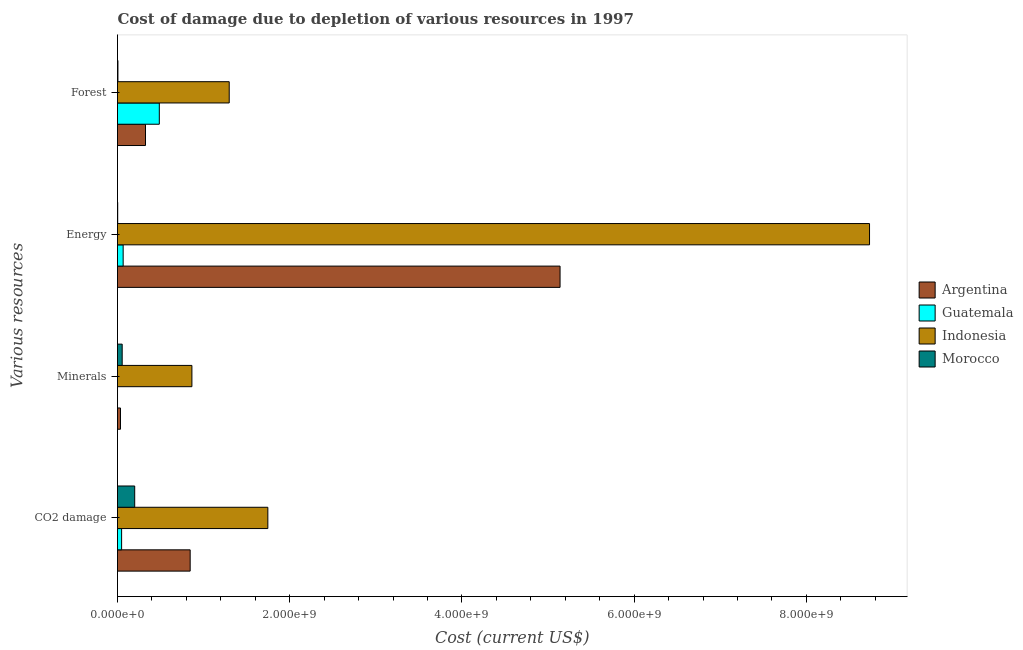Are the number of bars per tick equal to the number of legend labels?
Provide a succinct answer. Yes. How many bars are there on the 3rd tick from the top?
Your answer should be compact. 4. What is the label of the 1st group of bars from the top?
Give a very brief answer. Forest. What is the cost of damage due to depletion of energy in Morocco?
Ensure brevity in your answer.  2.38e+06. Across all countries, what is the maximum cost of damage due to depletion of forests?
Your answer should be compact. 1.30e+09. Across all countries, what is the minimum cost of damage due to depletion of forests?
Make the answer very short. 4.94e+06. In which country was the cost of damage due to depletion of forests maximum?
Give a very brief answer. Indonesia. In which country was the cost of damage due to depletion of energy minimum?
Your answer should be very brief. Morocco. What is the total cost of damage due to depletion of minerals in the graph?
Offer a very short reply. 9.53e+08. What is the difference between the cost of damage due to depletion of energy in Morocco and that in Argentina?
Your answer should be compact. -5.14e+09. What is the difference between the cost of damage due to depletion of forests in Morocco and the cost of damage due to depletion of coal in Indonesia?
Offer a very short reply. -1.74e+09. What is the average cost of damage due to depletion of minerals per country?
Ensure brevity in your answer.  2.38e+08. What is the difference between the cost of damage due to depletion of energy and cost of damage due to depletion of forests in Morocco?
Make the answer very short. -2.56e+06. What is the ratio of the cost of damage due to depletion of energy in Morocco to that in Indonesia?
Ensure brevity in your answer.  0. What is the difference between the highest and the second highest cost of damage due to depletion of forests?
Provide a succinct answer. 8.12e+08. What is the difference between the highest and the lowest cost of damage due to depletion of minerals?
Provide a short and direct response. 8.64e+08. In how many countries, is the cost of damage due to depletion of coal greater than the average cost of damage due to depletion of coal taken over all countries?
Provide a short and direct response. 2. Is the sum of the cost of damage due to depletion of coal in Indonesia and Guatemala greater than the maximum cost of damage due to depletion of minerals across all countries?
Provide a short and direct response. Yes. Is it the case that in every country, the sum of the cost of damage due to depletion of minerals and cost of damage due to depletion of coal is greater than the sum of cost of damage due to depletion of forests and cost of damage due to depletion of energy?
Your answer should be very brief. No. What does the 2nd bar from the top in Minerals represents?
Provide a short and direct response. Indonesia. What does the 1st bar from the bottom in CO2 damage represents?
Keep it short and to the point. Argentina. Is it the case that in every country, the sum of the cost of damage due to depletion of coal and cost of damage due to depletion of minerals is greater than the cost of damage due to depletion of energy?
Offer a terse response. No. Are all the bars in the graph horizontal?
Make the answer very short. Yes. Are the values on the major ticks of X-axis written in scientific E-notation?
Offer a very short reply. Yes. Does the graph contain grids?
Make the answer very short. No. Where does the legend appear in the graph?
Ensure brevity in your answer.  Center right. How are the legend labels stacked?
Ensure brevity in your answer.  Vertical. What is the title of the graph?
Your answer should be compact. Cost of damage due to depletion of various resources in 1997 . What is the label or title of the X-axis?
Your answer should be compact. Cost (current US$). What is the label or title of the Y-axis?
Keep it short and to the point. Various resources. What is the Cost (current US$) of Argentina in CO2 damage?
Keep it short and to the point. 8.44e+08. What is the Cost (current US$) in Guatemala in CO2 damage?
Ensure brevity in your answer.  4.76e+07. What is the Cost (current US$) of Indonesia in CO2 damage?
Offer a very short reply. 1.75e+09. What is the Cost (current US$) in Morocco in CO2 damage?
Offer a very short reply. 2.00e+08. What is the Cost (current US$) in Argentina in Minerals?
Your answer should be compact. 3.46e+07. What is the Cost (current US$) of Guatemala in Minerals?
Provide a succinct answer. 8.35e+04. What is the Cost (current US$) in Indonesia in Minerals?
Your answer should be compact. 8.64e+08. What is the Cost (current US$) in Morocco in Minerals?
Provide a short and direct response. 5.44e+07. What is the Cost (current US$) in Argentina in Energy?
Your answer should be very brief. 5.14e+09. What is the Cost (current US$) of Guatemala in Energy?
Offer a terse response. 6.56e+07. What is the Cost (current US$) in Indonesia in Energy?
Make the answer very short. 8.73e+09. What is the Cost (current US$) of Morocco in Energy?
Keep it short and to the point. 2.38e+06. What is the Cost (current US$) of Argentina in Forest?
Your response must be concise. 3.25e+08. What is the Cost (current US$) in Guatemala in Forest?
Keep it short and to the point. 4.85e+08. What is the Cost (current US$) of Indonesia in Forest?
Your answer should be compact. 1.30e+09. What is the Cost (current US$) of Morocco in Forest?
Offer a very short reply. 4.94e+06. Across all Various resources, what is the maximum Cost (current US$) in Argentina?
Your answer should be very brief. 5.14e+09. Across all Various resources, what is the maximum Cost (current US$) in Guatemala?
Ensure brevity in your answer.  4.85e+08. Across all Various resources, what is the maximum Cost (current US$) in Indonesia?
Keep it short and to the point. 8.73e+09. Across all Various resources, what is the maximum Cost (current US$) of Morocco?
Keep it short and to the point. 2.00e+08. Across all Various resources, what is the minimum Cost (current US$) in Argentina?
Ensure brevity in your answer.  3.46e+07. Across all Various resources, what is the minimum Cost (current US$) in Guatemala?
Offer a terse response. 8.35e+04. Across all Various resources, what is the minimum Cost (current US$) in Indonesia?
Your answer should be compact. 8.64e+08. Across all Various resources, what is the minimum Cost (current US$) in Morocco?
Ensure brevity in your answer.  2.38e+06. What is the total Cost (current US$) of Argentina in the graph?
Offer a terse response. 6.34e+09. What is the total Cost (current US$) of Guatemala in the graph?
Keep it short and to the point. 5.99e+08. What is the total Cost (current US$) in Indonesia in the graph?
Provide a succinct answer. 1.26e+1. What is the total Cost (current US$) of Morocco in the graph?
Your response must be concise. 2.61e+08. What is the difference between the Cost (current US$) of Argentina in CO2 damage and that in Minerals?
Your answer should be compact. 8.09e+08. What is the difference between the Cost (current US$) in Guatemala in CO2 damage and that in Minerals?
Give a very brief answer. 4.75e+07. What is the difference between the Cost (current US$) in Indonesia in CO2 damage and that in Minerals?
Make the answer very short. 8.82e+08. What is the difference between the Cost (current US$) in Morocco in CO2 damage and that in Minerals?
Your answer should be very brief. 1.45e+08. What is the difference between the Cost (current US$) of Argentina in CO2 damage and that in Energy?
Provide a succinct answer. -4.30e+09. What is the difference between the Cost (current US$) of Guatemala in CO2 damage and that in Energy?
Your answer should be very brief. -1.80e+07. What is the difference between the Cost (current US$) in Indonesia in CO2 damage and that in Energy?
Keep it short and to the point. -6.99e+09. What is the difference between the Cost (current US$) of Morocco in CO2 damage and that in Energy?
Your response must be concise. 1.97e+08. What is the difference between the Cost (current US$) of Argentina in CO2 damage and that in Forest?
Your answer should be very brief. 5.19e+08. What is the difference between the Cost (current US$) in Guatemala in CO2 damage and that in Forest?
Provide a succinct answer. -4.38e+08. What is the difference between the Cost (current US$) in Indonesia in CO2 damage and that in Forest?
Give a very brief answer. 4.49e+08. What is the difference between the Cost (current US$) of Morocco in CO2 damage and that in Forest?
Offer a terse response. 1.95e+08. What is the difference between the Cost (current US$) in Argentina in Minerals and that in Energy?
Your answer should be very brief. -5.10e+09. What is the difference between the Cost (current US$) in Guatemala in Minerals and that in Energy?
Offer a very short reply. -6.56e+07. What is the difference between the Cost (current US$) of Indonesia in Minerals and that in Energy?
Keep it short and to the point. -7.87e+09. What is the difference between the Cost (current US$) in Morocco in Minerals and that in Energy?
Give a very brief answer. 5.20e+07. What is the difference between the Cost (current US$) of Argentina in Minerals and that in Forest?
Your answer should be very brief. -2.91e+08. What is the difference between the Cost (current US$) in Guatemala in Minerals and that in Forest?
Your answer should be very brief. -4.85e+08. What is the difference between the Cost (current US$) of Indonesia in Minerals and that in Forest?
Give a very brief answer. -4.33e+08. What is the difference between the Cost (current US$) of Morocco in Minerals and that in Forest?
Give a very brief answer. 4.94e+07. What is the difference between the Cost (current US$) of Argentina in Energy and that in Forest?
Your answer should be compact. 4.81e+09. What is the difference between the Cost (current US$) in Guatemala in Energy and that in Forest?
Provide a short and direct response. -4.20e+08. What is the difference between the Cost (current US$) in Indonesia in Energy and that in Forest?
Your response must be concise. 7.44e+09. What is the difference between the Cost (current US$) of Morocco in Energy and that in Forest?
Your answer should be very brief. -2.56e+06. What is the difference between the Cost (current US$) in Argentina in CO2 damage and the Cost (current US$) in Guatemala in Minerals?
Offer a terse response. 8.44e+08. What is the difference between the Cost (current US$) in Argentina in CO2 damage and the Cost (current US$) in Indonesia in Minerals?
Make the answer very short. -2.02e+07. What is the difference between the Cost (current US$) in Argentina in CO2 damage and the Cost (current US$) in Morocco in Minerals?
Offer a terse response. 7.89e+08. What is the difference between the Cost (current US$) in Guatemala in CO2 damage and the Cost (current US$) in Indonesia in Minerals?
Provide a short and direct response. -8.16e+08. What is the difference between the Cost (current US$) of Guatemala in CO2 damage and the Cost (current US$) of Morocco in Minerals?
Keep it short and to the point. -6.76e+06. What is the difference between the Cost (current US$) in Indonesia in CO2 damage and the Cost (current US$) in Morocco in Minerals?
Your answer should be compact. 1.69e+09. What is the difference between the Cost (current US$) in Argentina in CO2 damage and the Cost (current US$) in Guatemala in Energy?
Ensure brevity in your answer.  7.78e+08. What is the difference between the Cost (current US$) in Argentina in CO2 damage and the Cost (current US$) in Indonesia in Energy?
Offer a terse response. -7.89e+09. What is the difference between the Cost (current US$) in Argentina in CO2 damage and the Cost (current US$) in Morocco in Energy?
Your answer should be compact. 8.41e+08. What is the difference between the Cost (current US$) in Guatemala in CO2 damage and the Cost (current US$) in Indonesia in Energy?
Provide a succinct answer. -8.69e+09. What is the difference between the Cost (current US$) of Guatemala in CO2 damage and the Cost (current US$) of Morocco in Energy?
Your answer should be compact. 4.52e+07. What is the difference between the Cost (current US$) of Indonesia in CO2 damage and the Cost (current US$) of Morocco in Energy?
Your response must be concise. 1.74e+09. What is the difference between the Cost (current US$) in Argentina in CO2 damage and the Cost (current US$) in Guatemala in Forest?
Your response must be concise. 3.58e+08. What is the difference between the Cost (current US$) of Argentina in CO2 damage and the Cost (current US$) of Indonesia in Forest?
Provide a succinct answer. -4.54e+08. What is the difference between the Cost (current US$) of Argentina in CO2 damage and the Cost (current US$) of Morocco in Forest?
Provide a succinct answer. 8.39e+08. What is the difference between the Cost (current US$) in Guatemala in CO2 damage and the Cost (current US$) in Indonesia in Forest?
Keep it short and to the point. -1.25e+09. What is the difference between the Cost (current US$) of Guatemala in CO2 damage and the Cost (current US$) of Morocco in Forest?
Provide a short and direct response. 4.27e+07. What is the difference between the Cost (current US$) of Indonesia in CO2 damage and the Cost (current US$) of Morocco in Forest?
Keep it short and to the point. 1.74e+09. What is the difference between the Cost (current US$) of Argentina in Minerals and the Cost (current US$) of Guatemala in Energy?
Provide a succinct answer. -3.10e+07. What is the difference between the Cost (current US$) in Argentina in Minerals and the Cost (current US$) in Indonesia in Energy?
Your response must be concise. -8.70e+09. What is the difference between the Cost (current US$) in Argentina in Minerals and the Cost (current US$) in Morocco in Energy?
Give a very brief answer. 3.22e+07. What is the difference between the Cost (current US$) in Guatemala in Minerals and the Cost (current US$) in Indonesia in Energy?
Offer a very short reply. -8.73e+09. What is the difference between the Cost (current US$) in Guatemala in Minerals and the Cost (current US$) in Morocco in Energy?
Make the answer very short. -2.30e+06. What is the difference between the Cost (current US$) in Indonesia in Minerals and the Cost (current US$) in Morocco in Energy?
Your answer should be very brief. 8.62e+08. What is the difference between the Cost (current US$) of Argentina in Minerals and the Cost (current US$) of Guatemala in Forest?
Your response must be concise. -4.51e+08. What is the difference between the Cost (current US$) of Argentina in Minerals and the Cost (current US$) of Indonesia in Forest?
Provide a short and direct response. -1.26e+09. What is the difference between the Cost (current US$) in Argentina in Minerals and the Cost (current US$) in Morocco in Forest?
Offer a terse response. 2.97e+07. What is the difference between the Cost (current US$) of Guatemala in Minerals and the Cost (current US$) of Indonesia in Forest?
Keep it short and to the point. -1.30e+09. What is the difference between the Cost (current US$) in Guatemala in Minerals and the Cost (current US$) in Morocco in Forest?
Your answer should be very brief. -4.85e+06. What is the difference between the Cost (current US$) in Indonesia in Minerals and the Cost (current US$) in Morocco in Forest?
Your response must be concise. 8.59e+08. What is the difference between the Cost (current US$) in Argentina in Energy and the Cost (current US$) in Guatemala in Forest?
Your answer should be compact. 4.65e+09. What is the difference between the Cost (current US$) in Argentina in Energy and the Cost (current US$) in Indonesia in Forest?
Your answer should be very brief. 3.84e+09. What is the difference between the Cost (current US$) of Argentina in Energy and the Cost (current US$) of Morocco in Forest?
Make the answer very short. 5.13e+09. What is the difference between the Cost (current US$) of Guatemala in Energy and the Cost (current US$) of Indonesia in Forest?
Provide a succinct answer. -1.23e+09. What is the difference between the Cost (current US$) of Guatemala in Energy and the Cost (current US$) of Morocco in Forest?
Make the answer very short. 6.07e+07. What is the difference between the Cost (current US$) of Indonesia in Energy and the Cost (current US$) of Morocco in Forest?
Your answer should be very brief. 8.73e+09. What is the average Cost (current US$) of Argentina per Various resources?
Provide a succinct answer. 1.59e+09. What is the average Cost (current US$) in Guatemala per Various resources?
Keep it short and to the point. 1.50e+08. What is the average Cost (current US$) in Indonesia per Various resources?
Give a very brief answer. 3.16e+09. What is the average Cost (current US$) of Morocco per Various resources?
Keep it short and to the point. 6.53e+07. What is the difference between the Cost (current US$) in Argentina and Cost (current US$) in Guatemala in CO2 damage?
Give a very brief answer. 7.96e+08. What is the difference between the Cost (current US$) of Argentina and Cost (current US$) of Indonesia in CO2 damage?
Offer a terse response. -9.02e+08. What is the difference between the Cost (current US$) in Argentina and Cost (current US$) in Morocco in CO2 damage?
Offer a terse response. 6.44e+08. What is the difference between the Cost (current US$) in Guatemala and Cost (current US$) in Indonesia in CO2 damage?
Keep it short and to the point. -1.70e+09. What is the difference between the Cost (current US$) of Guatemala and Cost (current US$) of Morocco in CO2 damage?
Your response must be concise. -1.52e+08. What is the difference between the Cost (current US$) in Indonesia and Cost (current US$) in Morocco in CO2 damage?
Your answer should be compact. 1.55e+09. What is the difference between the Cost (current US$) of Argentina and Cost (current US$) of Guatemala in Minerals?
Ensure brevity in your answer.  3.45e+07. What is the difference between the Cost (current US$) in Argentina and Cost (current US$) in Indonesia in Minerals?
Give a very brief answer. -8.29e+08. What is the difference between the Cost (current US$) of Argentina and Cost (current US$) of Morocco in Minerals?
Keep it short and to the point. -1.98e+07. What is the difference between the Cost (current US$) of Guatemala and Cost (current US$) of Indonesia in Minerals?
Keep it short and to the point. -8.64e+08. What is the difference between the Cost (current US$) of Guatemala and Cost (current US$) of Morocco in Minerals?
Give a very brief answer. -5.43e+07. What is the difference between the Cost (current US$) of Indonesia and Cost (current US$) of Morocco in Minerals?
Ensure brevity in your answer.  8.10e+08. What is the difference between the Cost (current US$) in Argentina and Cost (current US$) in Guatemala in Energy?
Offer a very short reply. 5.07e+09. What is the difference between the Cost (current US$) of Argentina and Cost (current US$) of Indonesia in Energy?
Your answer should be very brief. -3.59e+09. What is the difference between the Cost (current US$) in Argentina and Cost (current US$) in Morocco in Energy?
Your answer should be compact. 5.14e+09. What is the difference between the Cost (current US$) of Guatemala and Cost (current US$) of Indonesia in Energy?
Your answer should be compact. -8.67e+09. What is the difference between the Cost (current US$) of Guatemala and Cost (current US$) of Morocco in Energy?
Your answer should be compact. 6.33e+07. What is the difference between the Cost (current US$) in Indonesia and Cost (current US$) in Morocco in Energy?
Your answer should be compact. 8.73e+09. What is the difference between the Cost (current US$) in Argentina and Cost (current US$) in Guatemala in Forest?
Offer a very short reply. -1.60e+08. What is the difference between the Cost (current US$) in Argentina and Cost (current US$) in Indonesia in Forest?
Offer a very short reply. -9.72e+08. What is the difference between the Cost (current US$) of Argentina and Cost (current US$) of Morocco in Forest?
Offer a terse response. 3.20e+08. What is the difference between the Cost (current US$) in Guatemala and Cost (current US$) in Indonesia in Forest?
Provide a short and direct response. -8.12e+08. What is the difference between the Cost (current US$) of Guatemala and Cost (current US$) of Morocco in Forest?
Keep it short and to the point. 4.80e+08. What is the difference between the Cost (current US$) in Indonesia and Cost (current US$) in Morocco in Forest?
Offer a terse response. 1.29e+09. What is the ratio of the Cost (current US$) of Argentina in CO2 damage to that in Minerals?
Your answer should be compact. 24.39. What is the ratio of the Cost (current US$) in Guatemala in CO2 damage to that in Minerals?
Give a very brief answer. 569.95. What is the ratio of the Cost (current US$) of Indonesia in CO2 damage to that in Minerals?
Make the answer very short. 2.02. What is the ratio of the Cost (current US$) in Morocco in CO2 damage to that in Minerals?
Provide a succinct answer. 3.67. What is the ratio of the Cost (current US$) in Argentina in CO2 damage to that in Energy?
Your answer should be very brief. 0.16. What is the ratio of the Cost (current US$) of Guatemala in CO2 damage to that in Energy?
Ensure brevity in your answer.  0.73. What is the ratio of the Cost (current US$) in Indonesia in CO2 damage to that in Energy?
Offer a very short reply. 0.2. What is the ratio of the Cost (current US$) of Morocco in CO2 damage to that in Energy?
Offer a very short reply. 83.87. What is the ratio of the Cost (current US$) in Argentina in CO2 damage to that in Forest?
Make the answer very short. 2.6. What is the ratio of the Cost (current US$) in Guatemala in CO2 damage to that in Forest?
Your response must be concise. 0.1. What is the ratio of the Cost (current US$) of Indonesia in CO2 damage to that in Forest?
Give a very brief answer. 1.35. What is the ratio of the Cost (current US$) in Morocco in CO2 damage to that in Forest?
Offer a terse response. 40.43. What is the ratio of the Cost (current US$) in Argentina in Minerals to that in Energy?
Your response must be concise. 0.01. What is the ratio of the Cost (current US$) of Guatemala in Minerals to that in Energy?
Keep it short and to the point. 0. What is the ratio of the Cost (current US$) of Indonesia in Minerals to that in Energy?
Keep it short and to the point. 0.1. What is the ratio of the Cost (current US$) in Morocco in Minerals to that in Energy?
Offer a terse response. 22.84. What is the ratio of the Cost (current US$) of Argentina in Minerals to that in Forest?
Provide a succinct answer. 0.11. What is the ratio of the Cost (current US$) in Guatemala in Minerals to that in Forest?
Your response must be concise. 0. What is the ratio of the Cost (current US$) in Indonesia in Minerals to that in Forest?
Provide a short and direct response. 0.67. What is the ratio of the Cost (current US$) in Morocco in Minerals to that in Forest?
Make the answer very short. 11.01. What is the ratio of the Cost (current US$) in Argentina in Energy to that in Forest?
Ensure brevity in your answer.  15.81. What is the ratio of the Cost (current US$) of Guatemala in Energy to that in Forest?
Your answer should be very brief. 0.14. What is the ratio of the Cost (current US$) in Indonesia in Energy to that in Forest?
Make the answer very short. 6.73. What is the ratio of the Cost (current US$) of Morocco in Energy to that in Forest?
Offer a terse response. 0.48. What is the difference between the highest and the second highest Cost (current US$) in Argentina?
Your response must be concise. 4.30e+09. What is the difference between the highest and the second highest Cost (current US$) in Guatemala?
Provide a succinct answer. 4.20e+08. What is the difference between the highest and the second highest Cost (current US$) of Indonesia?
Your answer should be very brief. 6.99e+09. What is the difference between the highest and the second highest Cost (current US$) in Morocco?
Offer a terse response. 1.45e+08. What is the difference between the highest and the lowest Cost (current US$) in Argentina?
Keep it short and to the point. 5.10e+09. What is the difference between the highest and the lowest Cost (current US$) in Guatemala?
Provide a short and direct response. 4.85e+08. What is the difference between the highest and the lowest Cost (current US$) in Indonesia?
Your response must be concise. 7.87e+09. What is the difference between the highest and the lowest Cost (current US$) in Morocco?
Make the answer very short. 1.97e+08. 